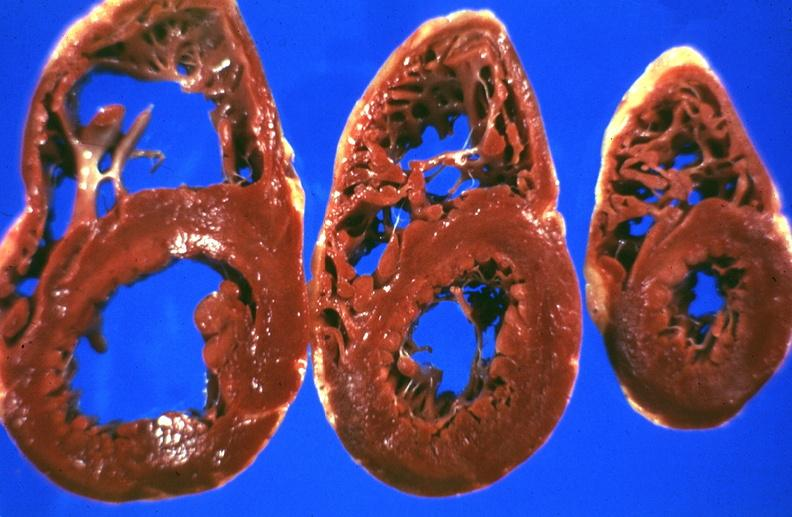does surface show liver, hemochromatosis?
Answer the question using a single word or phrase. No 